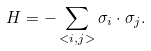Convert formula to latex. <formula><loc_0><loc_0><loc_500><loc_500>H = - \sum _ { < i , j > } \sigma _ { i } \cdot \sigma _ { j } .</formula> 